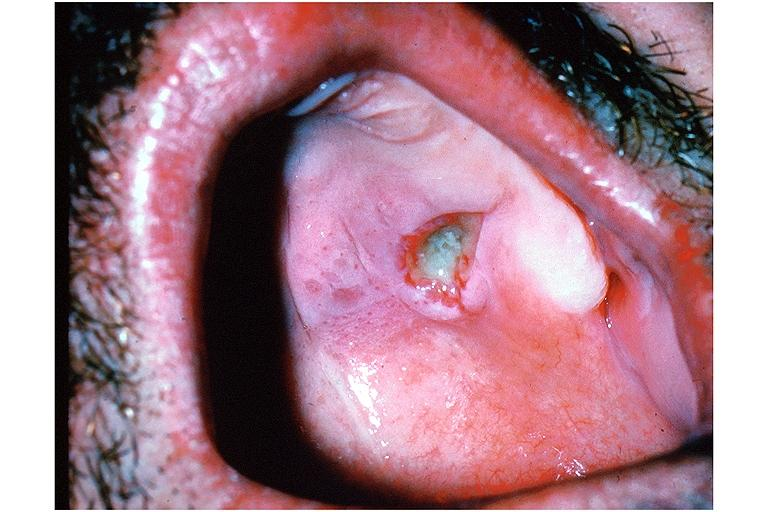s oral present?
Answer the question using a single word or phrase. Yes 